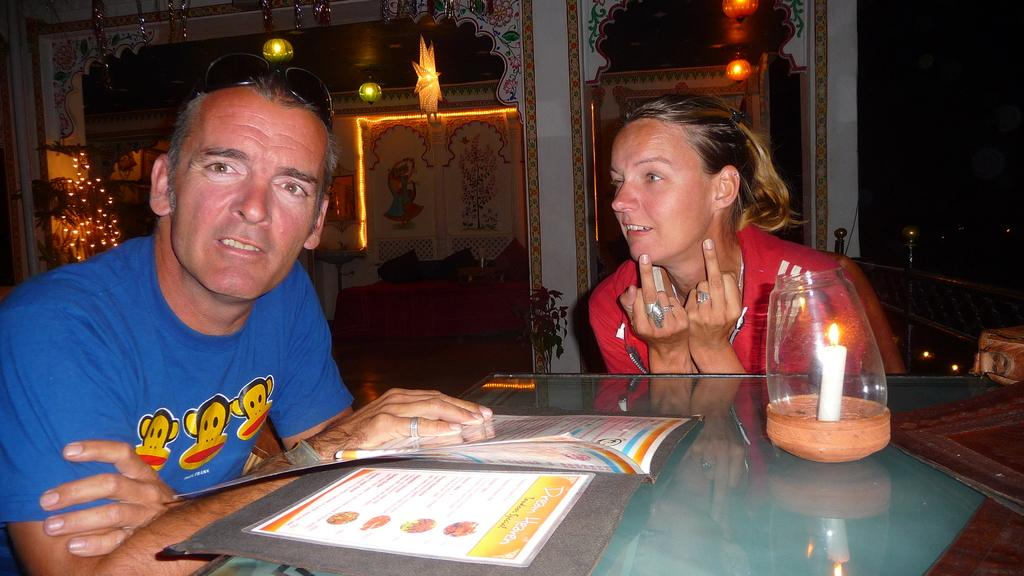How many people are in the image? There are two people in the image, a man and a woman. What are the man and woman doing in the image? They are sitting in front of a table. What are they holding in the image? They are holding a menu. What can be seen hanging from the wall in the image? Stars and balls are hanging from the wall. What type of cub can be seen playing in the wilderness in the image? There is no cub or wilderness present in the image; it features a man and a woman sitting at a table with a menu. How are they transporting themselves to their destination in the image? The image does not show any form of transportation, as the man and woman are sitting at a table. 